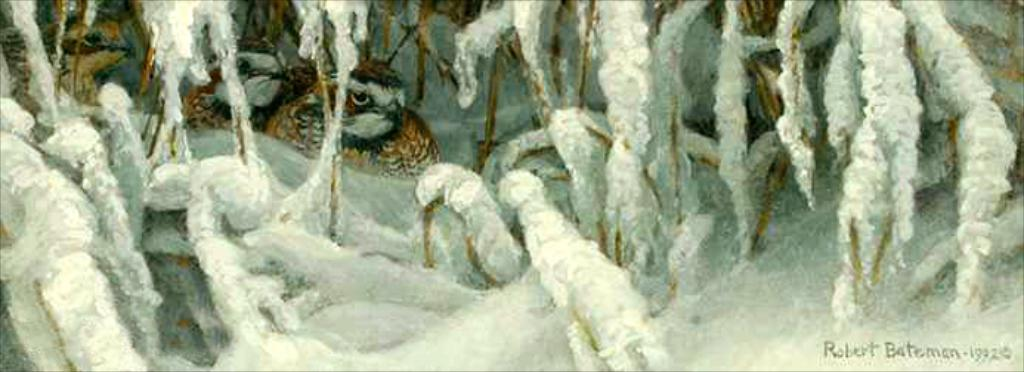What type of animals can be seen in the image? There are birds in the image. What is the weather like in the image? There is snow in the image, indicating a cold environment. Is there any additional information or branding present in the image? Yes, there is a watermark in the image. What type of medical advice can be seen in the image? There is no medical advice or doctor present in the image; it features birds in the snow with a watermark. How many frogs are visible in the image? There are no frogs present in the image; it features birds in the snow with a watermark. 